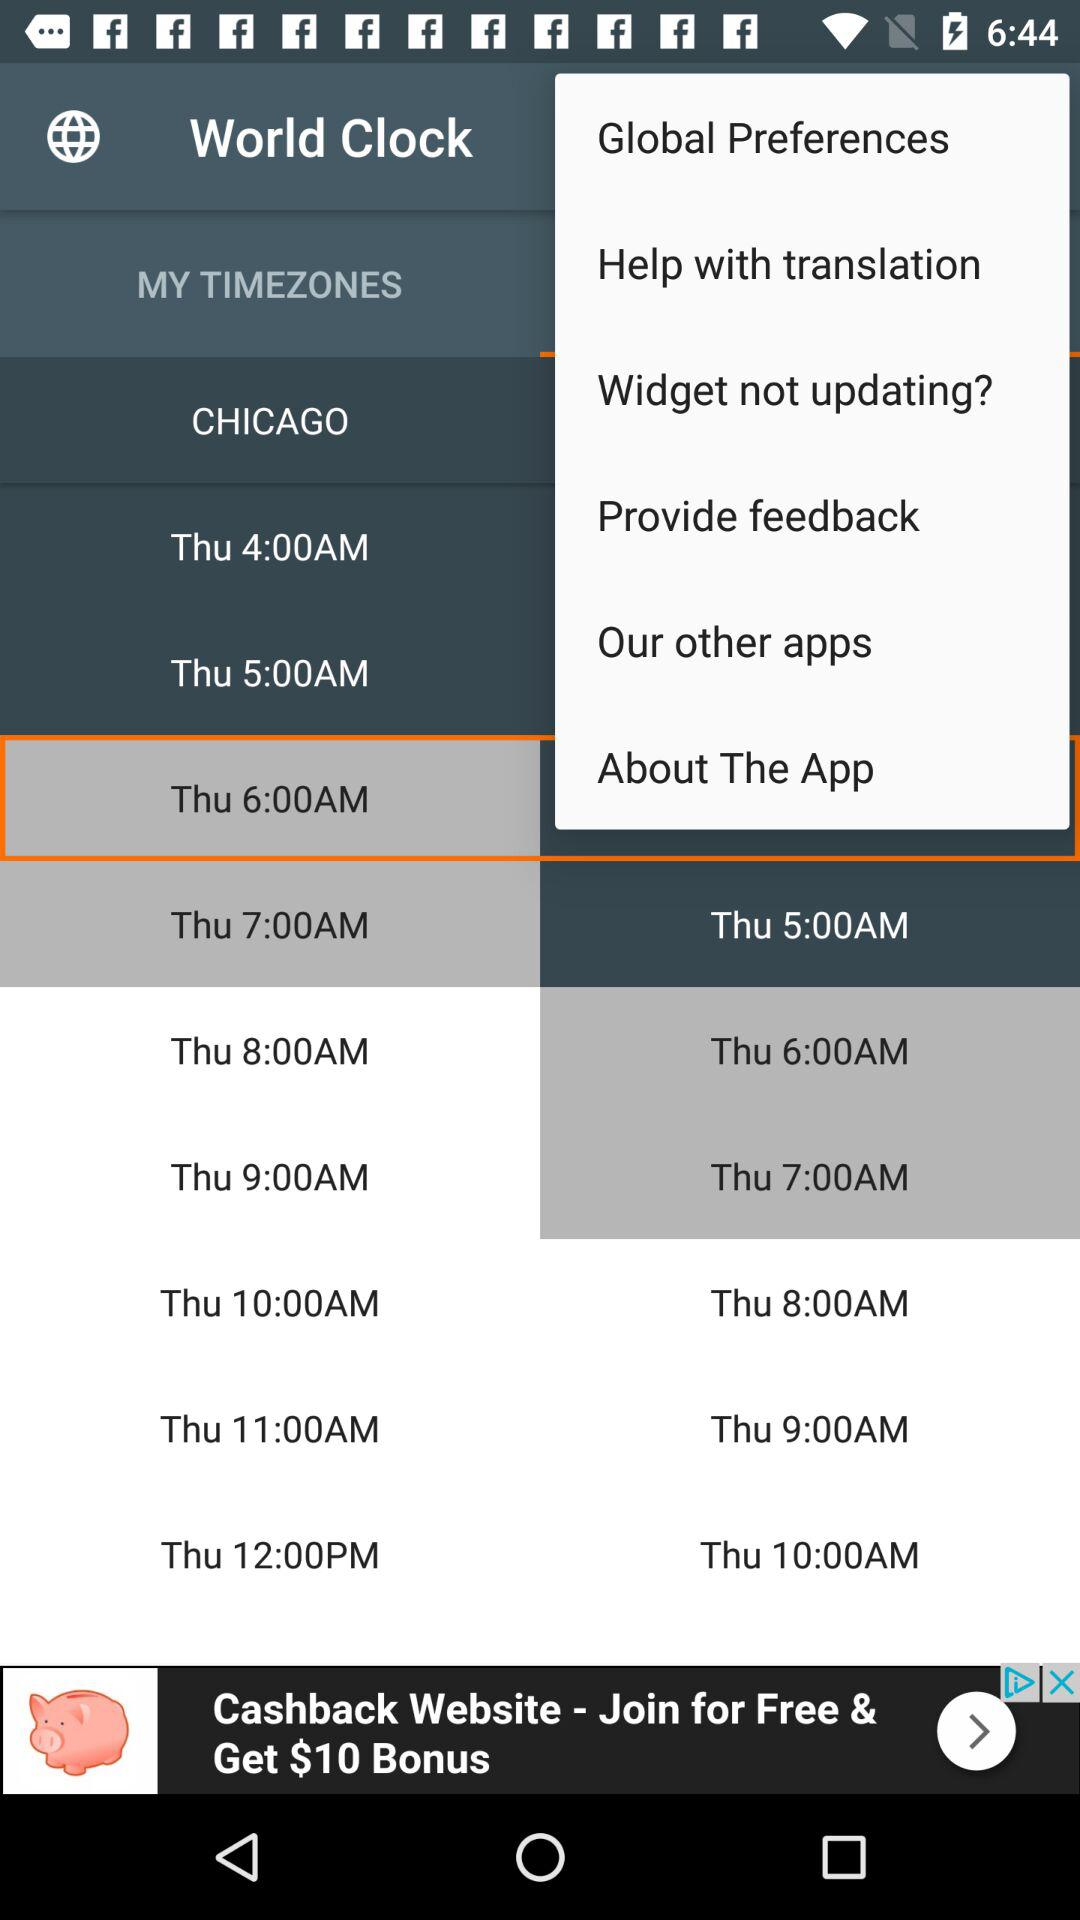What timezone is selected? The selected timezone is "CHICAGO". 